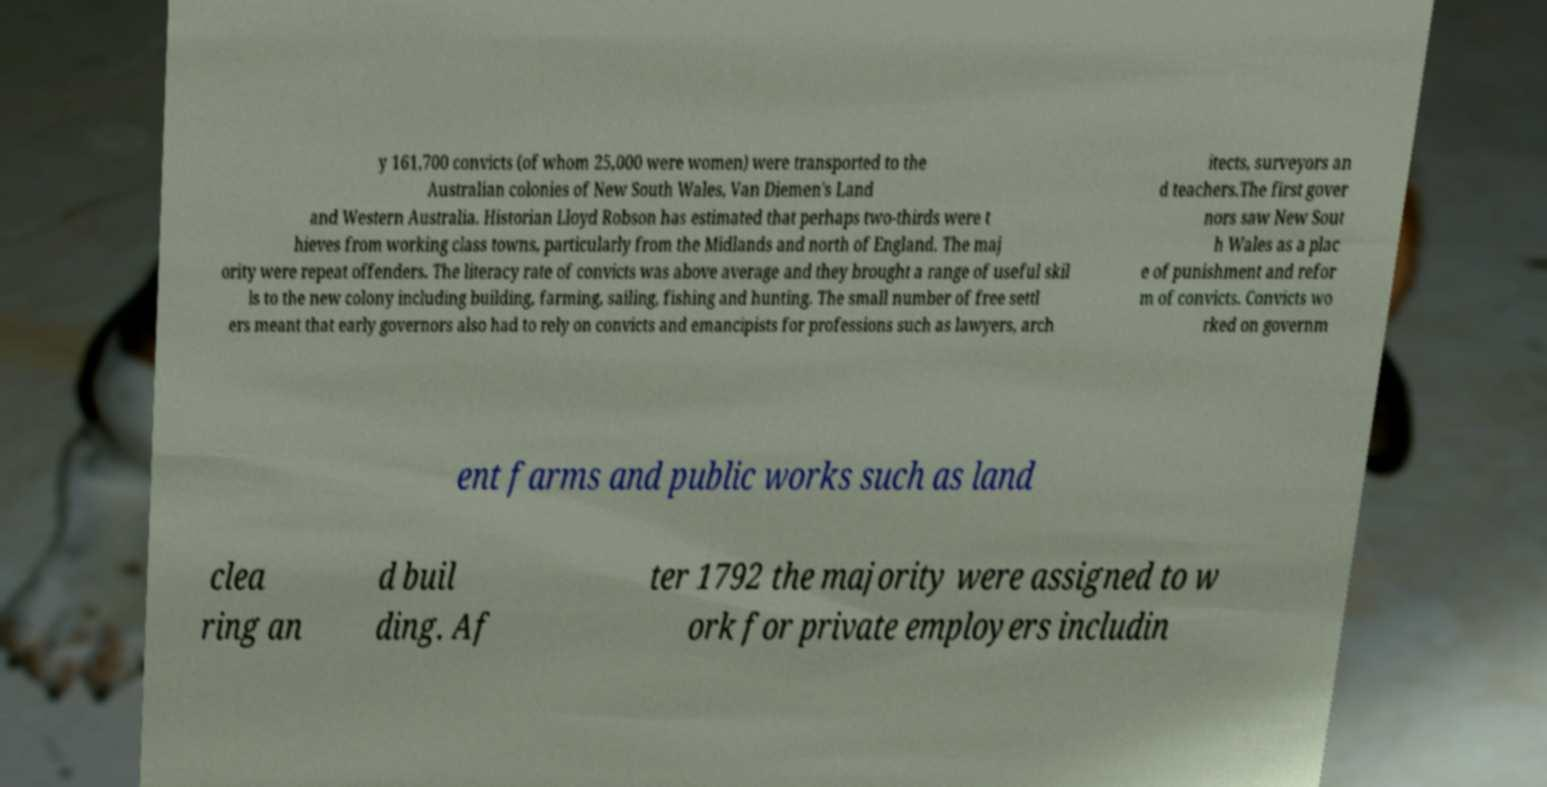Please identify and transcribe the text found in this image. y 161,700 convicts (of whom 25,000 were women) were transported to the Australian colonies of New South Wales, Van Diemen's Land and Western Australia. Historian Lloyd Robson has estimated that perhaps two-thirds were t hieves from working class towns, particularly from the Midlands and north of England. The maj ority were repeat offenders. The literacy rate of convicts was above average and they brought a range of useful skil ls to the new colony including building, farming, sailing, fishing and hunting. The small number of free settl ers meant that early governors also had to rely on convicts and emancipists for professions such as lawyers, arch itects, surveyors an d teachers.The first gover nors saw New Sout h Wales as a plac e of punishment and refor m of convicts. Convicts wo rked on governm ent farms and public works such as land clea ring an d buil ding. Af ter 1792 the majority were assigned to w ork for private employers includin 